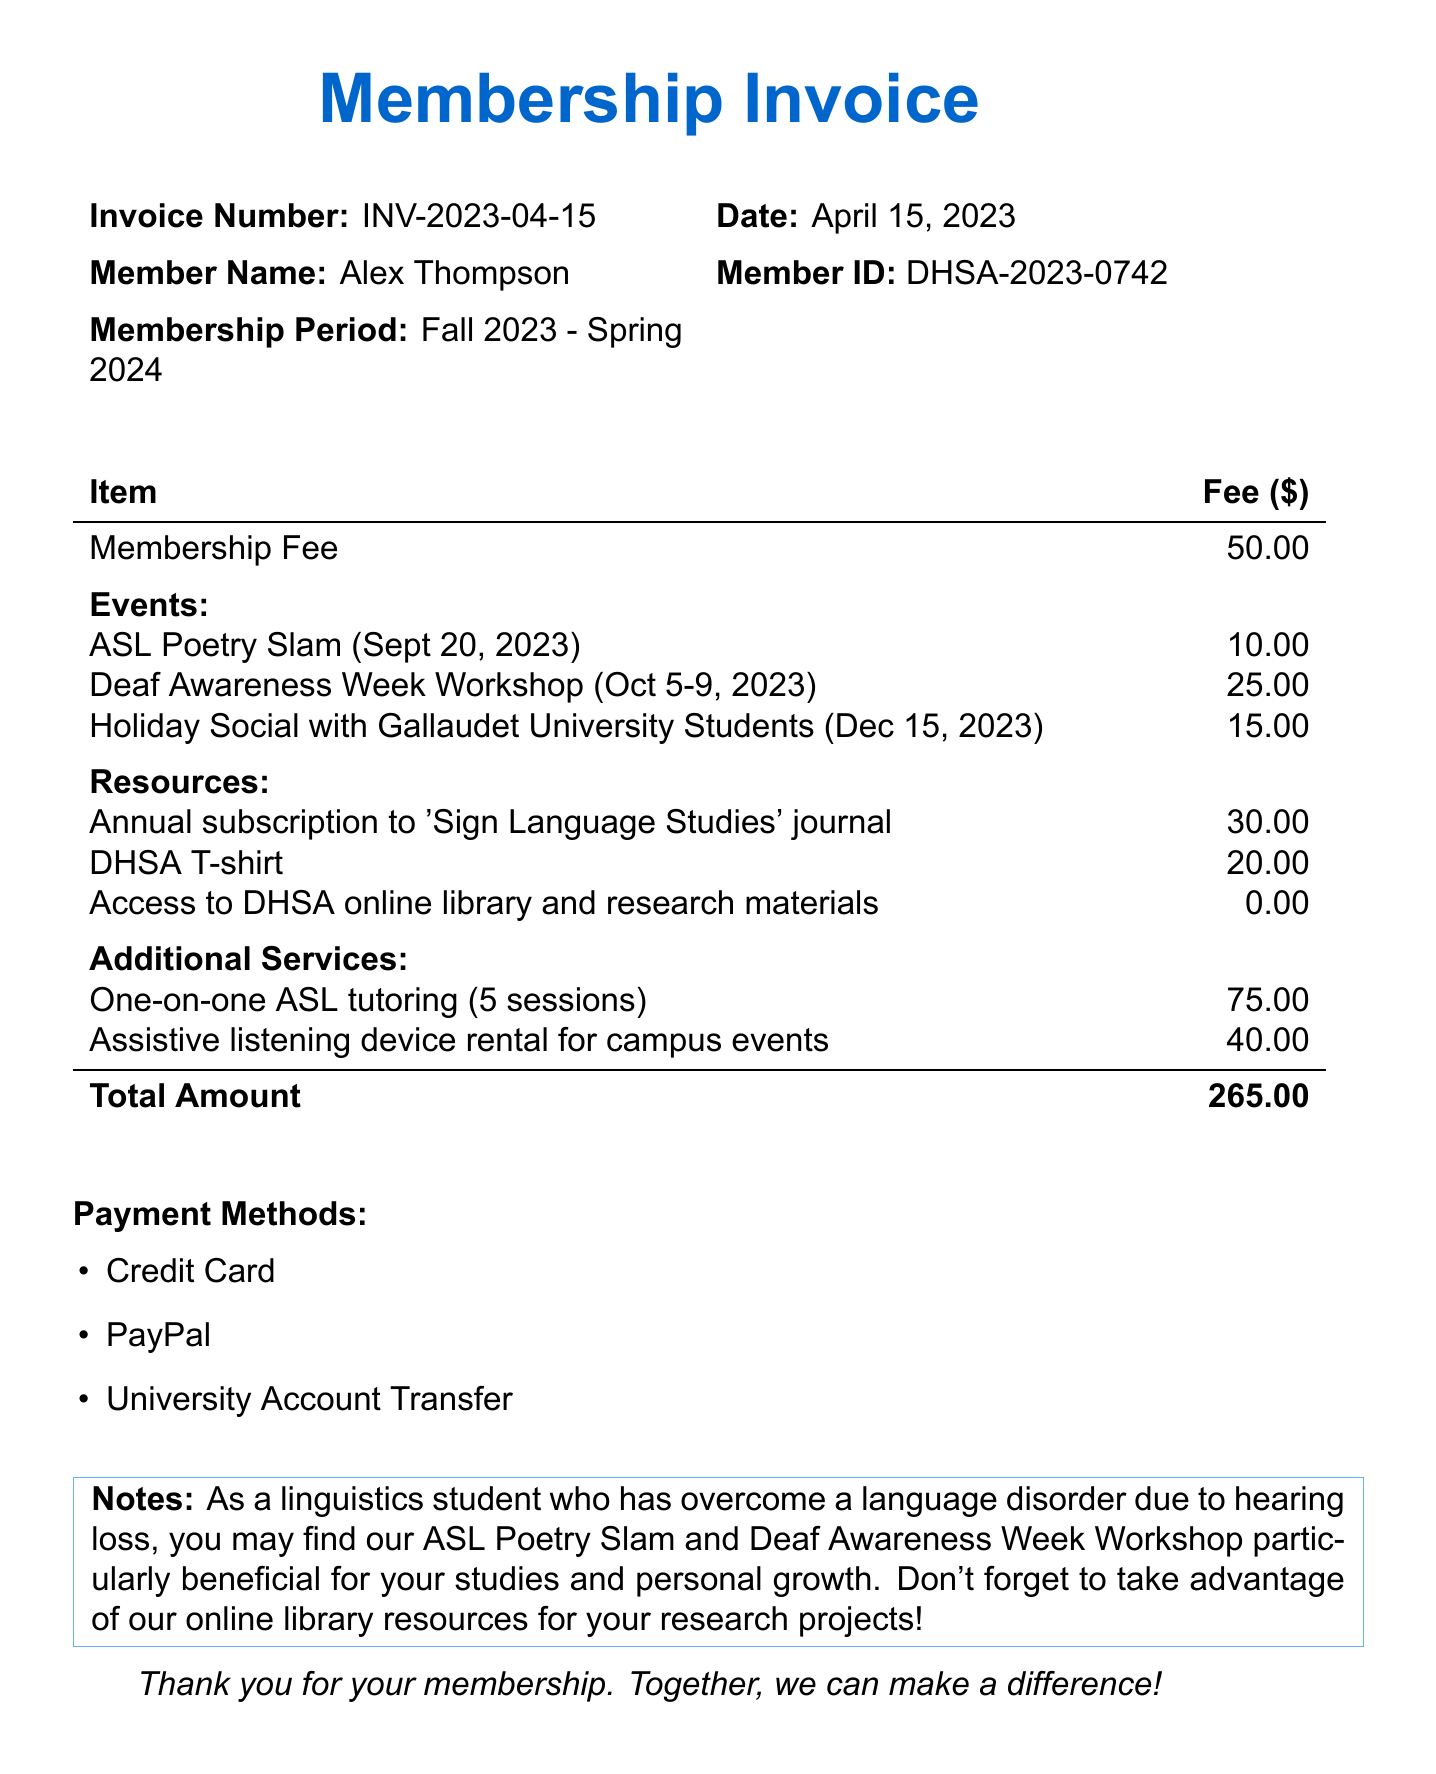What is the organization name? The organization name can be found at the top of the document.
Answer: Deaf and Hard of Hearing Student Association (DHSA) What is the invoice number? The invoice number is listed in the document's details section.
Answer: INV-2023-04-15 What is the membership fee? The membership fee is explicitly stated in the list of items with fees.
Answer: 50.00 When is the ASL Poetry Slam event? The date of the ASL Poetry Slam is mentioned next to the event name in the document.
Answer: September 20, 2023 What is the total amount due? The total amount can be found at the bottom of the fees table.
Answer: 265.00 What resources are included in the membership? This refers to a section detailing the resources and their fees listed in the document.
Answer: Annual subscription to 'Sign Language Studies' journal, DHSA T-shirt, Access to DHSA online library and research materials How many events are listed in the invoice? This can be answered by counting the number of events mentioned in the events section of the document.
Answer: 3 What are the payment methods available? The payment methods are outlined in a list format in the document.
Answer: Credit Card, PayPal, University Account Transfer What additional service has the highest fee? This requires comparing the fees listed under additional services.
Answer: One-on-one ASL tutoring (5 sessions) 